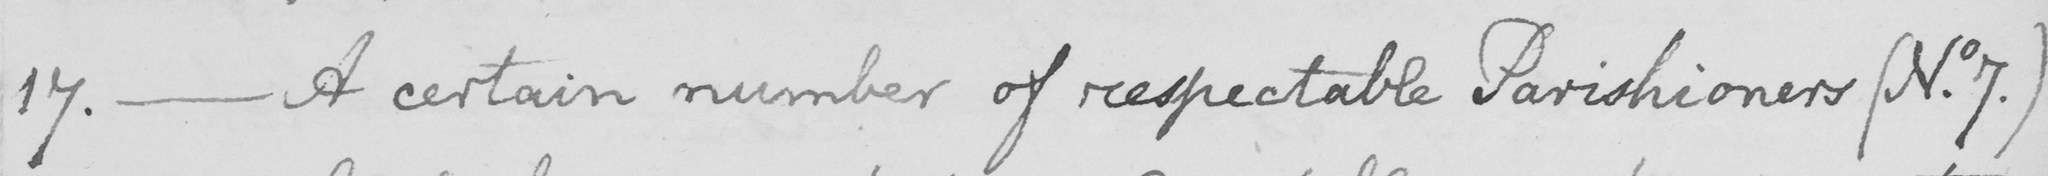Can you tell me what this handwritten text says? 17 .  _  A certain number of respectable Parishioners  ( No . 7 . ) 